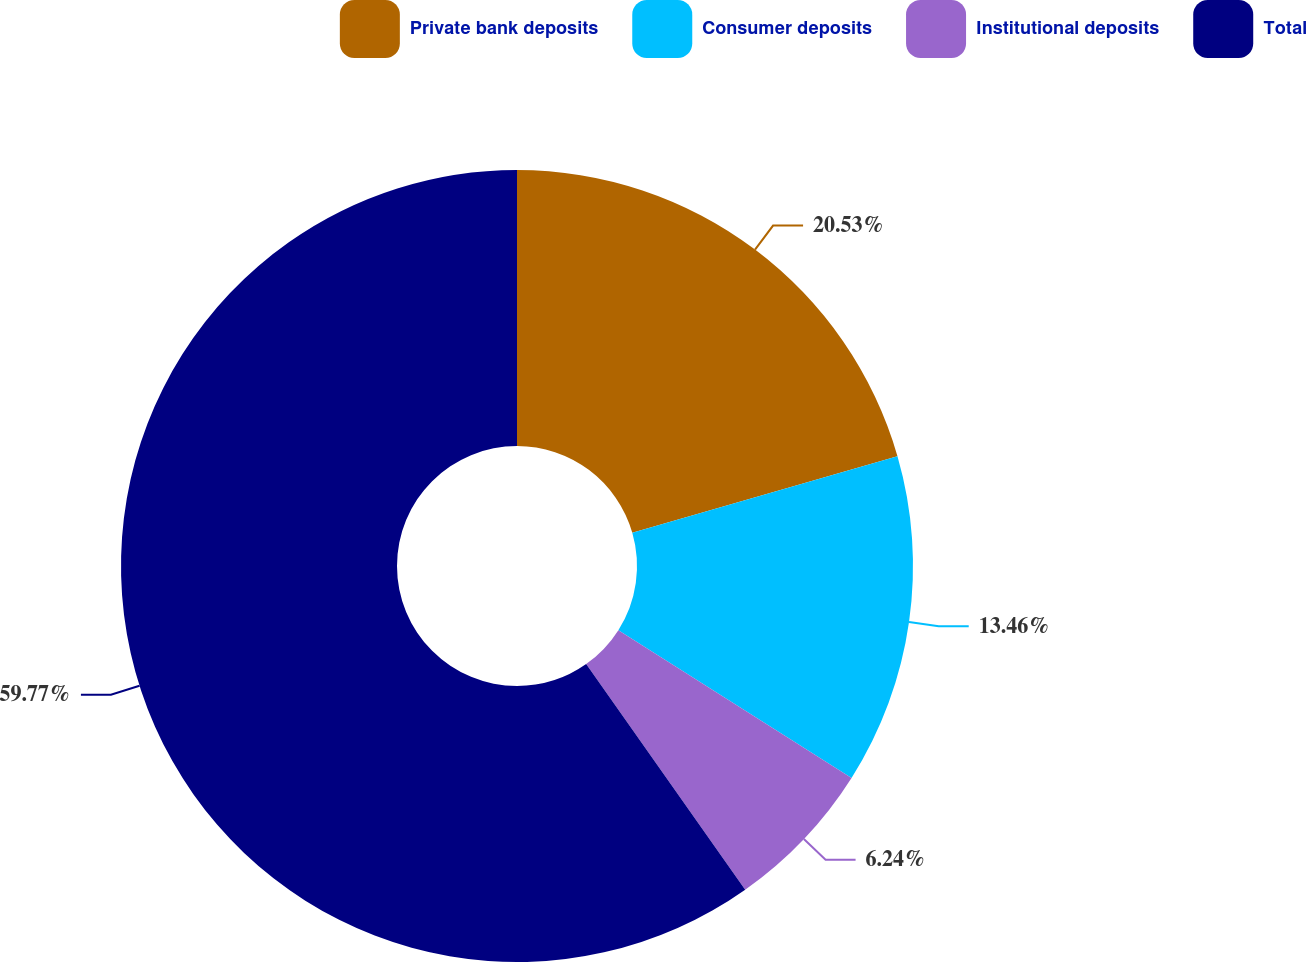<chart> <loc_0><loc_0><loc_500><loc_500><pie_chart><fcel>Private bank deposits<fcel>Consumer deposits<fcel>Institutional deposits<fcel>Total<nl><fcel>20.53%<fcel>13.46%<fcel>6.24%<fcel>59.78%<nl></chart> 